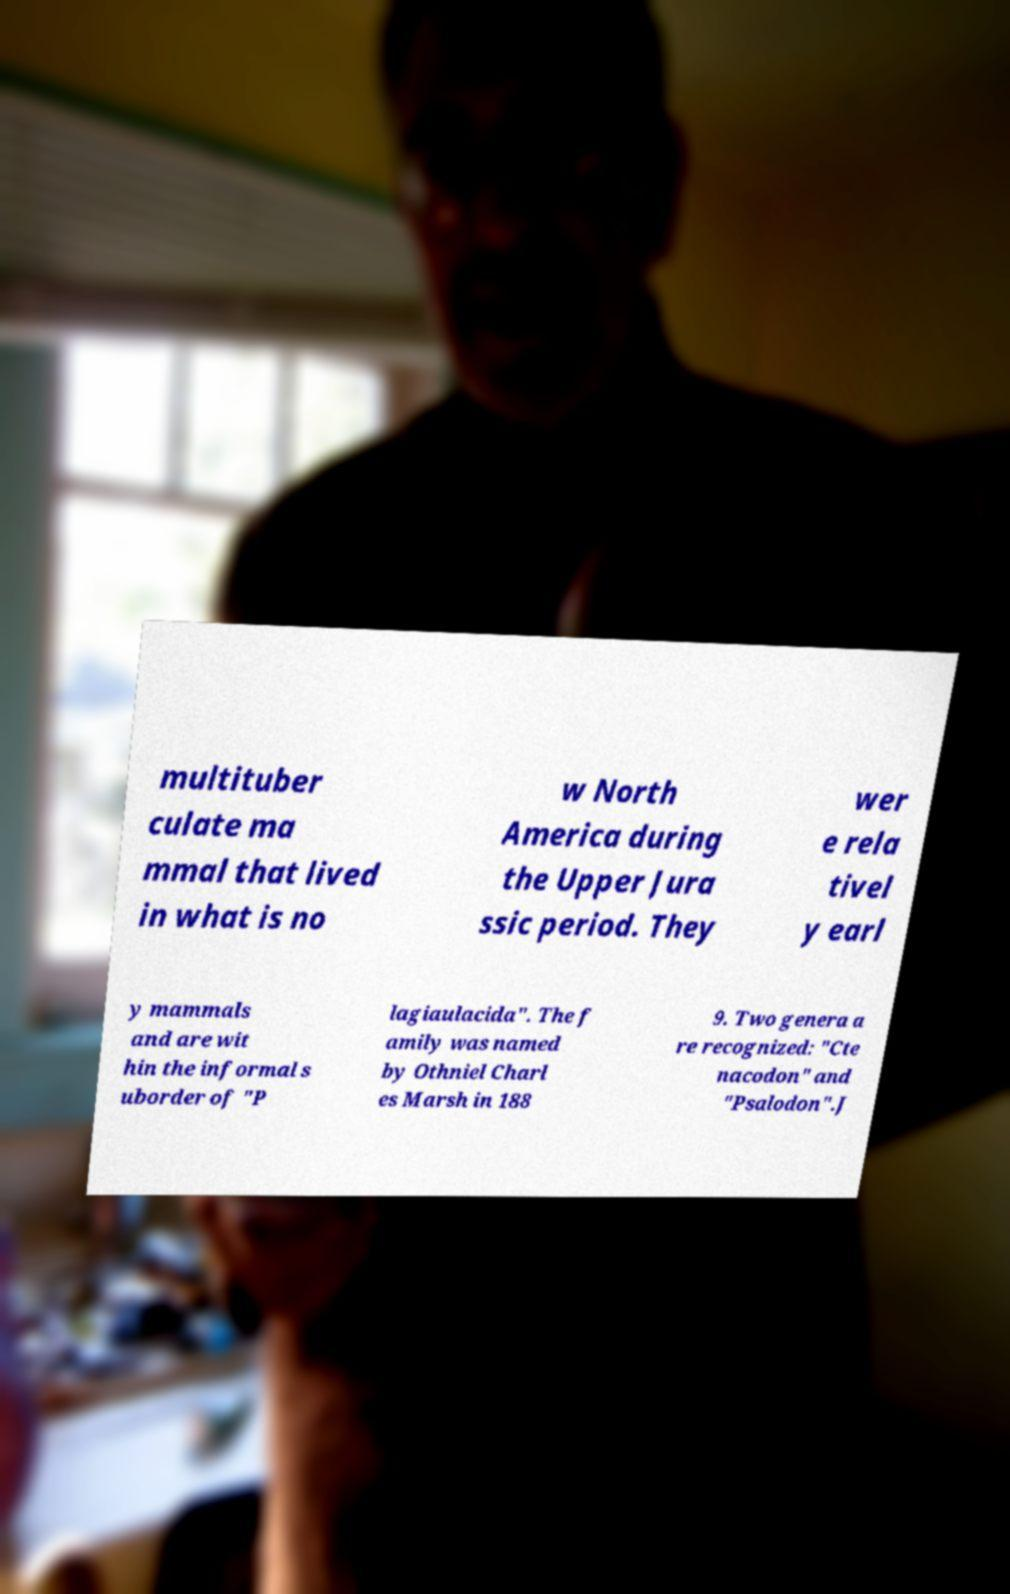Please read and relay the text visible in this image. What does it say? multituber culate ma mmal that lived in what is no w North America during the Upper Jura ssic period. They wer e rela tivel y earl y mammals and are wit hin the informal s uborder of "P lagiaulacida". The f amily was named by Othniel Charl es Marsh in 188 9. Two genera a re recognized: "Cte nacodon" and "Psalodon".J 